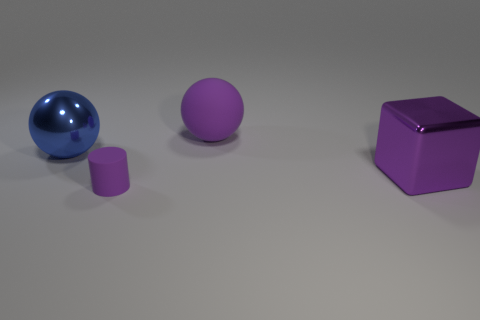Add 4 large brown blocks. How many objects exist? 8 Subtract all cylinders. How many objects are left? 3 Add 3 blue shiny spheres. How many blue shiny spheres exist? 4 Subtract 0 gray cylinders. How many objects are left? 4 Subtract all purple balls. Subtract all big matte things. How many objects are left? 2 Add 2 purple metallic cubes. How many purple metallic cubes are left? 3 